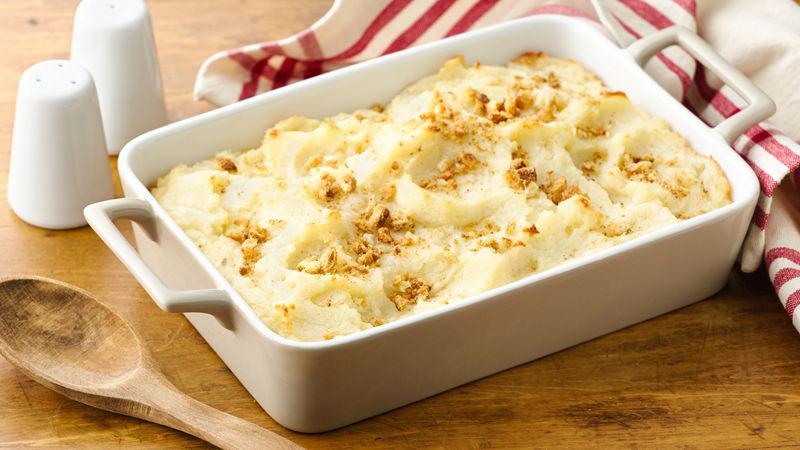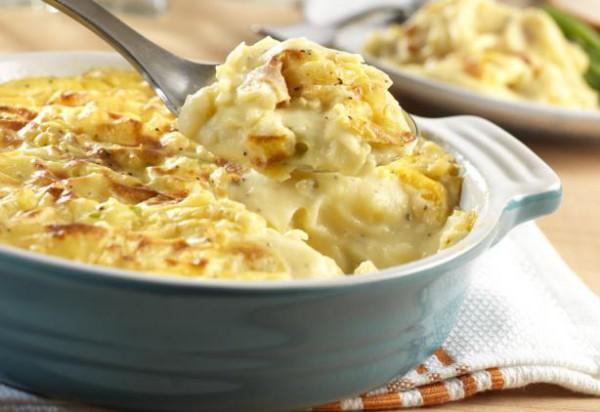The first image is the image on the left, the second image is the image on the right. Evaluate the accuracy of this statement regarding the images: "A casserole is in a white rectangular baking dish with chopped green chives on top.". Is it true? Answer yes or no. No. The first image is the image on the left, the second image is the image on the right. Considering the images on both sides, is "the casserole dish on the image in the right side is rectangular and white." valid? Answer yes or no. No. 